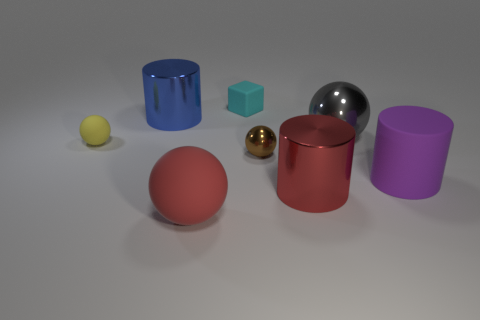Add 2 shiny things. How many objects exist? 10 Subtract all cubes. How many objects are left? 7 Subtract all big matte things. Subtract all metallic cylinders. How many objects are left? 4 Add 3 cyan things. How many cyan things are left? 4 Add 8 gray balls. How many gray balls exist? 9 Subtract 1 purple cylinders. How many objects are left? 7 